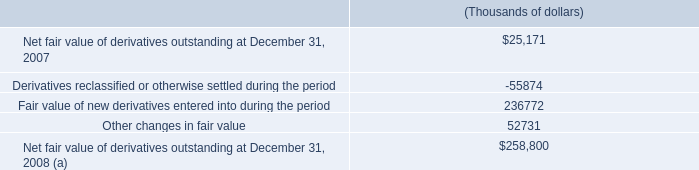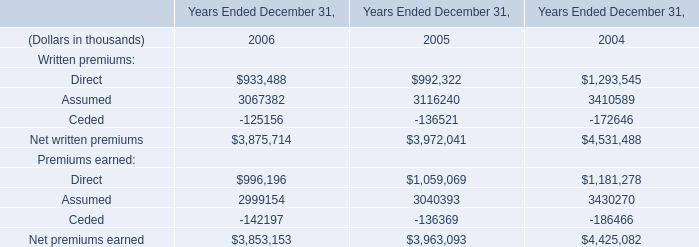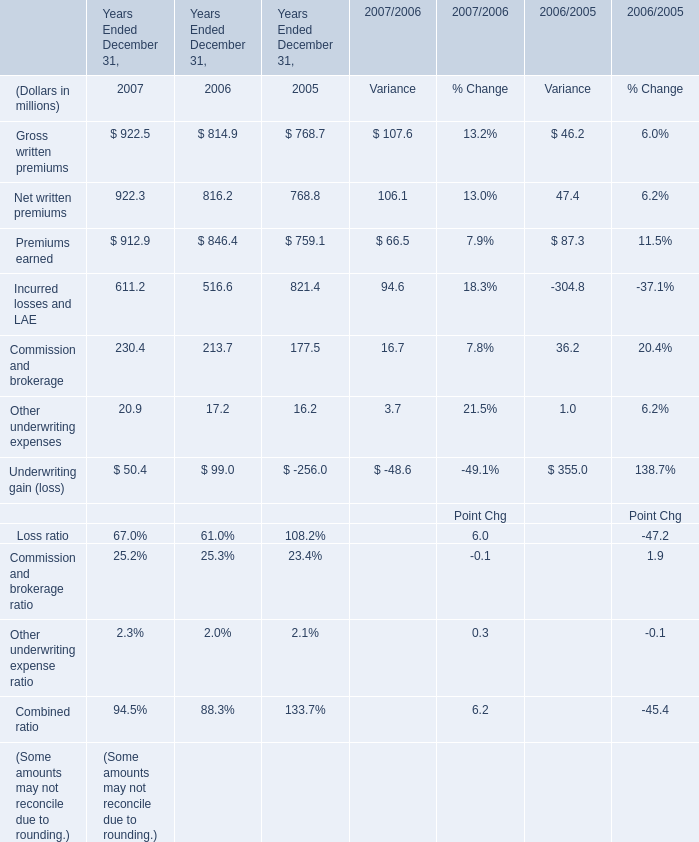What's the increasing rate of Net written premiums in 2006 Ended December 31? 
Computations: ((816.2 - 768.8) / 768.8)
Answer: 0.06165. 